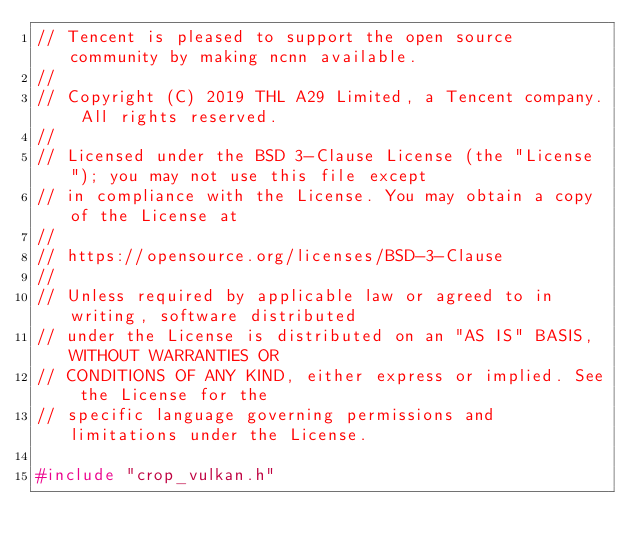Convert code to text. <code><loc_0><loc_0><loc_500><loc_500><_C++_>// Tencent is pleased to support the open source community by making ncnn available.
//
// Copyright (C) 2019 THL A29 Limited, a Tencent company. All rights reserved.
//
// Licensed under the BSD 3-Clause License (the "License"); you may not use this file except
// in compliance with the License. You may obtain a copy of the License at
//
// https://opensource.org/licenses/BSD-3-Clause
//
// Unless required by applicable law or agreed to in writing, software distributed
// under the License is distributed on an "AS IS" BASIS, WITHOUT WARRANTIES OR
// CONDITIONS OF ANY KIND, either express or implied. See the License for the
// specific language governing permissions and limitations under the License.

#include "crop_vulkan.h"
</code> 